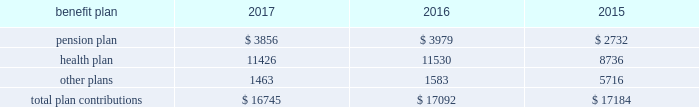112 / sl green realty corp .
2017 annual report 20 .
Commitments and contingencies legal proceedings as of december a031 , 2017 , the company and the operating partnership were not involved in any material litigation nor , to management 2019s knowledge , was any material litigation threat- ened against us or our portfolio which if adversely determined could have a material adverse impact on us .
Environmental matters our management believes that the properties are in compliance in all material respects with applicable federal , state and local ordinances and regulations regarding environmental issues .
Management is not aware of any environmental liability that it believes would have a materially adverse impact on our financial position , results of operations or cash flows .
Management is unaware of any instances in which it would incur significant envi- ronmental cost if any of our properties were sold .
Employment agreements we have entered into employment agreements with certain exec- utives , which expire between december a02018 and february a02020 .
The minimum cash-based compensation , including base sal- ary and guaranteed bonus payments , associated with these employment agreements total $ 5.4 a0million for 2018 .
In addition these employment agreements provide for deferred compen- sation awards based on our stock price and which were valued at $ 1.6 a0million on the grant date .
The value of these awards may change based on fluctuations in our stock price .
Insurance we maintain 201call-risk 201d property and rental value coverage ( includ- ing coverage regarding the perils of flood , earthquake and terrorism , excluding nuclear , biological , chemical , and radiological terrorism ( 201cnbcr 201d ) ) , within three property insurance programs and liability insurance .
Separate property and liability coverage may be purchased on a stand-alone basis for certain assets , such as the development of one vanderbilt .
Additionally , our captive insurance company , belmont insurance company , or belmont , pro- vides coverage for nbcr terrorist acts above a specified trigger , although if belmont is required to pay a claim under our insur- ance policies , we would ultimately record the loss to the extent of belmont 2019s required payment .
However , there is no assurance that in the future we will be able to procure coverage at a reasonable cost .
Further , if we experience losses that are uninsured or that exceed policy limits , we could lose the capital invested in the damaged properties as well as the anticipated future cash flows from those plan trustees adopted a rehabilitation plan consistent with this requirement .
No surcharges have been paid to the pension plan as of december a031 , 2017 .
For the pension plan years ended june a030 , 2017 , 2016 , and 2015 , the plan received contributions from employers totaling $ 257.8 a0million , $ 249.5 a0million , and $ 221.9 a0million .
Our contributions to the pension plan represent less than 5.0% ( 5.0 % ) of total contributions to the plan .
The health plan was established under the terms of collective bargaining agreements between the union , the realty advisory board on labor relations , inc .
And certain other employees .
The health plan provides health and other benefits to eligible participants employed in the building service industry who are covered under collective bargaining agreements , or other writ- ten agreements , with the union .
The health plan is administered by a board of trustees with equal representation by the employ- ers and the union and operates under employer identification number a013-2928869 .
The health plan receives contributions in accordance with collective bargaining agreements or participa- tion agreements .
Generally , these agreements provide that the employers contribute to the health plan at a fixed rate on behalf of each covered employee .
For the health plan years ended , june a030 , 2017 , 2016 , and 2015 , the plan received contributions from employers totaling $ 1.3 a0billion , $ 1.2 a0billion and $ 1.1 a0billion , respectively .
Our contributions to the health plan represent less than 5.0% ( 5.0 % ) of total contributions to the plan .
Contributions we made to the multi-employer plans for the years ended december a031 , 2017 , 2016 and 2015 are included in the table below ( in thousands ) : .
401 ( k ) plan in august a01997 , we implemented a 401 ( k ) a0savings/retirement plan , or the 401 ( k ) a0plan , to cover eligible employees of ours , and any designated affiliate .
The 401 ( k ) a0plan permits eligible employees to defer up to 15% ( 15 % ) of their annual compensation , subject to certain limitations imposed by the code .
The employees 2019 elective deferrals are immediately vested and non-forfeitable upon contribution to the 401 ( k ) a0plan .
During a02003 , we amended our 401 ( k ) a0plan to pro- vide for discretionary matching contributions only .
For 2017 , 2016 and 2015 , a matching contribution equal to 50% ( 50 % ) of the first 6% ( 6 % ) of annual compensation was made .
For the year ended december a031 , 2017 , we made a matching contribution of $ 728782 .
For the years ended december a031 , 2016 and 2015 , we made matching contribu- tions of $ 566000 and $ 550000 , respectively. .
For the years ended december 31 , 2016 and 2015 , what were total matching contributions? 
Computations: (566000 + 550000)
Answer: 1116000.0. 